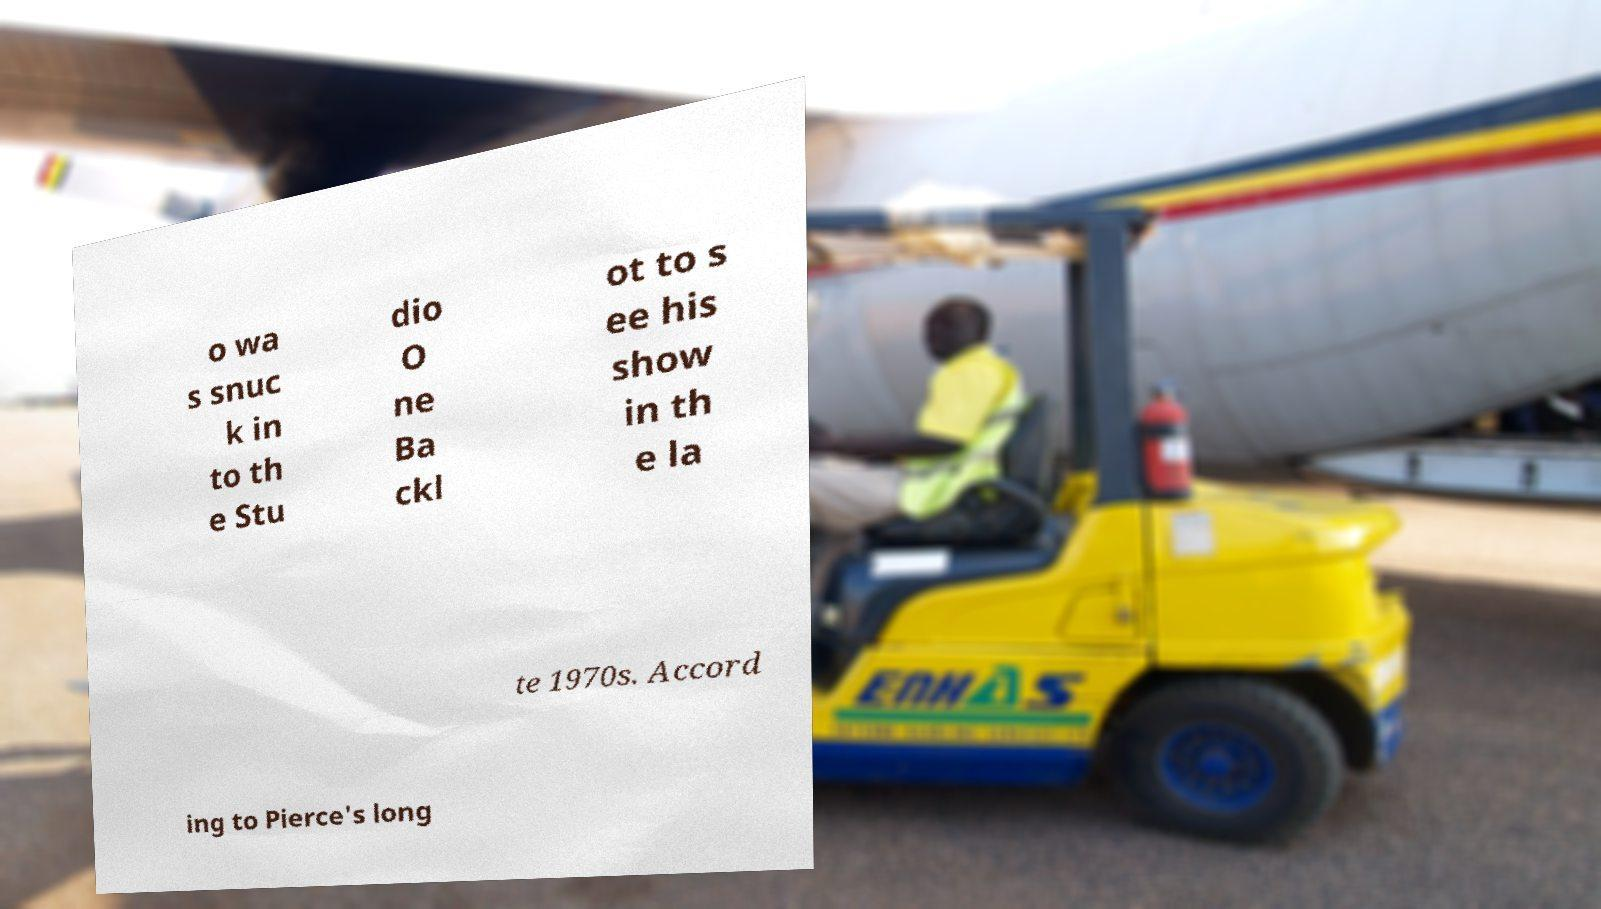Please identify and transcribe the text found in this image. o wa s snuc k in to th e Stu dio O ne Ba ckl ot to s ee his show in th e la te 1970s. Accord ing to Pierce's long 